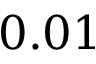Convert formula to latex. <formula><loc_0><loc_0><loc_500><loc_500>0 . 0 1</formula> 